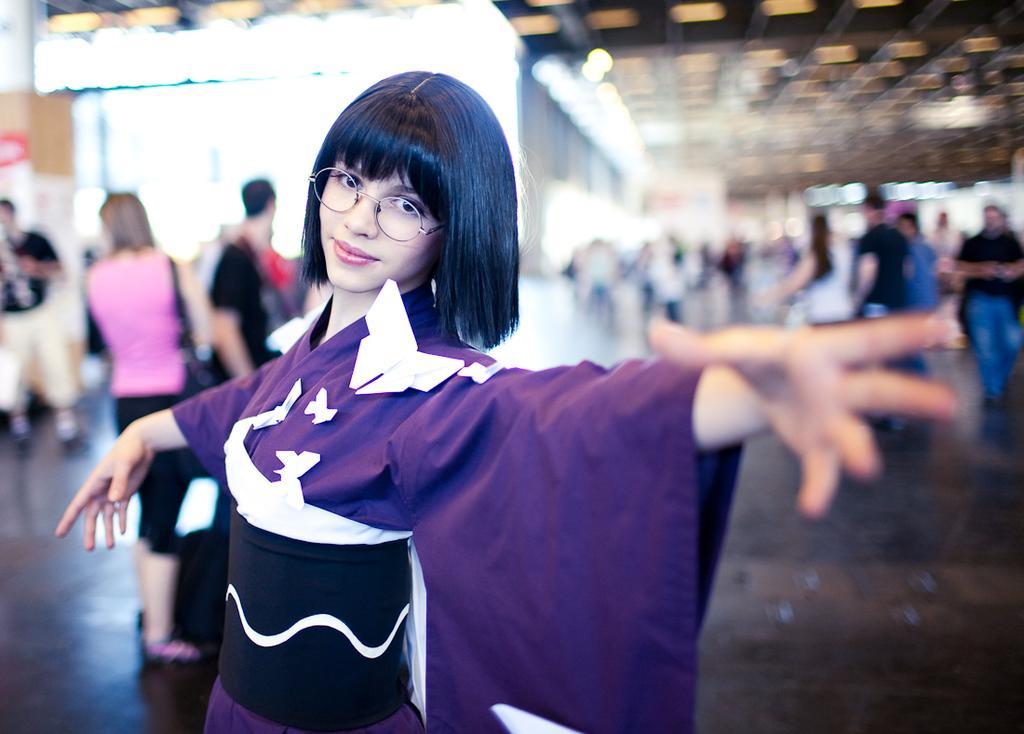Could you give a brief overview of what you see in this image? In the image we can see a woman standing, wearing clothes and spectacles. Behind here, there are other people standing and some of them are walking and the background is blurred. 